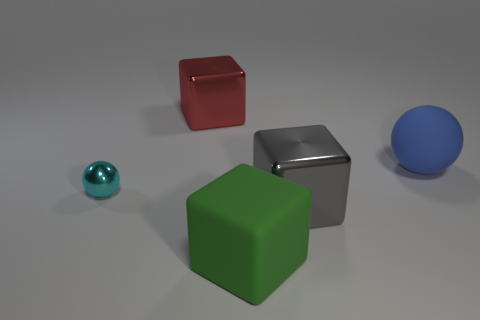What is the blue sphere made of?
Your response must be concise. Rubber. How many other objects are the same size as the matte ball?
Make the answer very short. 3. There is a thing that is behind the blue rubber object; what is its size?
Offer a terse response. Large. What is the material of the sphere that is to the right of the metallic block behind the metal cube in front of the small thing?
Give a very brief answer. Rubber. Is the red object the same shape as the green rubber object?
Your answer should be compact. Yes. What number of matte things are either small things or big red cubes?
Make the answer very short. 0. How many large green rubber blocks are there?
Offer a terse response. 1. What color is the sphere that is the same size as the green matte cube?
Offer a very short reply. Blue. Does the green matte thing have the same size as the blue object?
Provide a short and direct response. Yes. There is a cyan sphere; is it the same size as the thing behind the big matte ball?
Your response must be concise. No. 